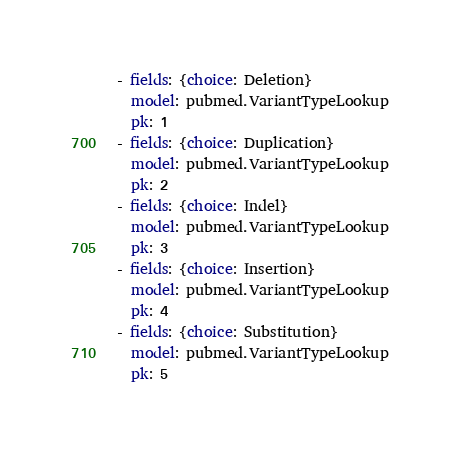<code> <loc_0><loc_0><loc_500><loc_500><_YAML_>- fields: {choice: Deletion}
  model: pubmed.VariantTypeLookup
  pk: 1
- fields: {choice: Duplication}
  model: pubmed.VariantTypeLookup
  pk: 2
- fields: {choice: Indel}
  model: pubmed.VariantTypeLookup
  pk: 3
- fields: {choice: Insertion}
  model: pubmed.VariantTypeLookup
  pk: 4
- fields: {choice: Substitution}
  model: pubmed.VariantTypeLookup
  pk: 5
</code> 